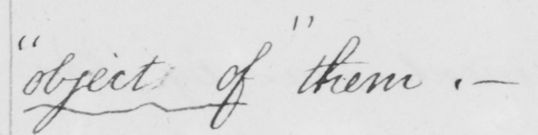Please transcribe the handwritten text in this image. " object of "  them .  _ 